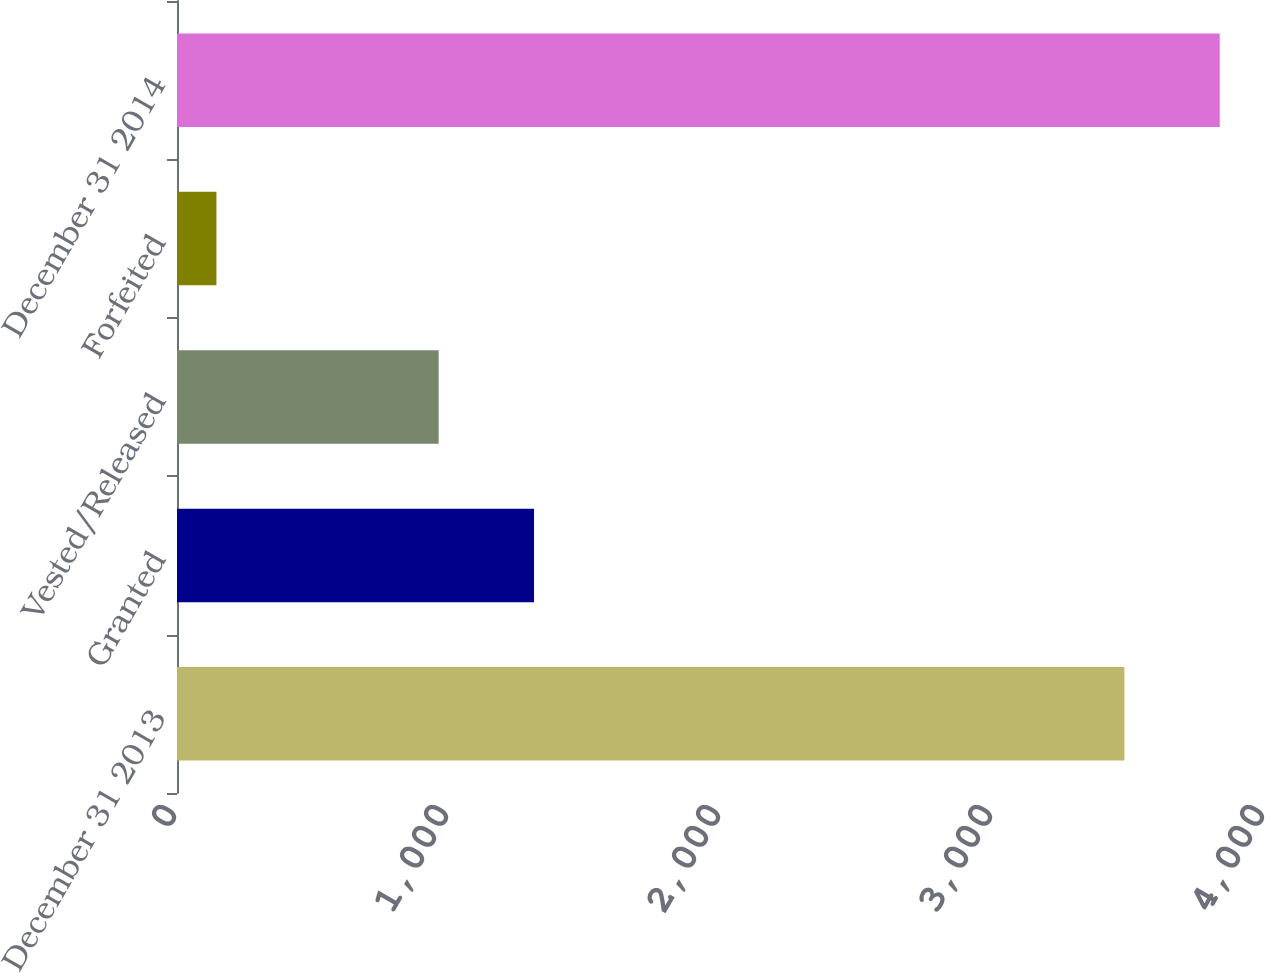Convert chart to OTSL. <chart><loc_0><loc_0><loc_500><loc_500><bar_chart><fcel>December 31 2013<fcel>Granted<fcel>Vested/Released<fcel>Forfeited<fcel>December 31 2014<nl><fcel>3483<fcel>1312.7<fcel>962<fcel>145<fcel>3833.7<nl></chart> 